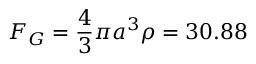Convert formula to latex. <formula><loc_0><loc_0><loc_500><loc_500>F _ { G } = \frac { 4 } { 3 } \pi a ^ { 3 } \rho = 3 0 . 8 8</formula> 